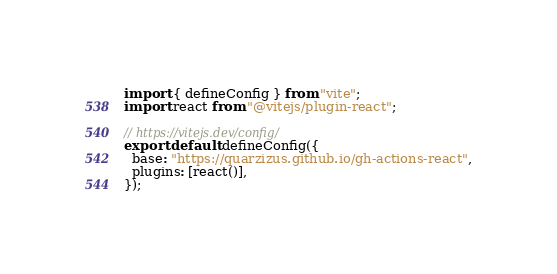<code> <loc_0><loc_0><loc_500><loc_500><_JavaScript_>import { defineConfig } from "vite";
import react from "@vitejs/plugin-react";

// https://vitejs.dev/config/
export default defineConfig({
  base: "https://quarzizus.github.io/gh-actions-react",
  plugins: [react()],
});
</code> 